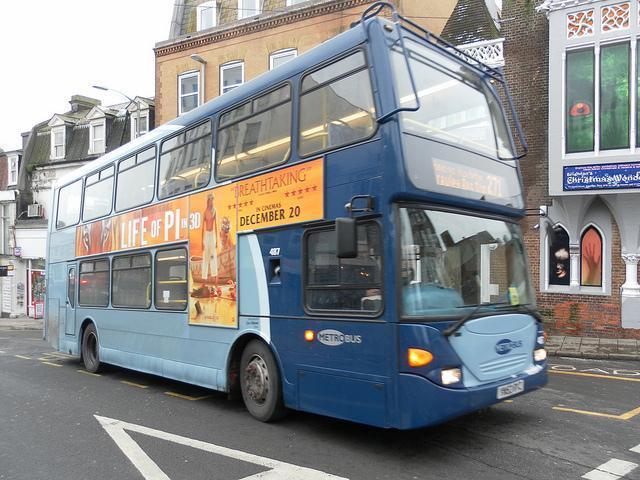How many people are wearing black?
Give a very brief answer. 0. 